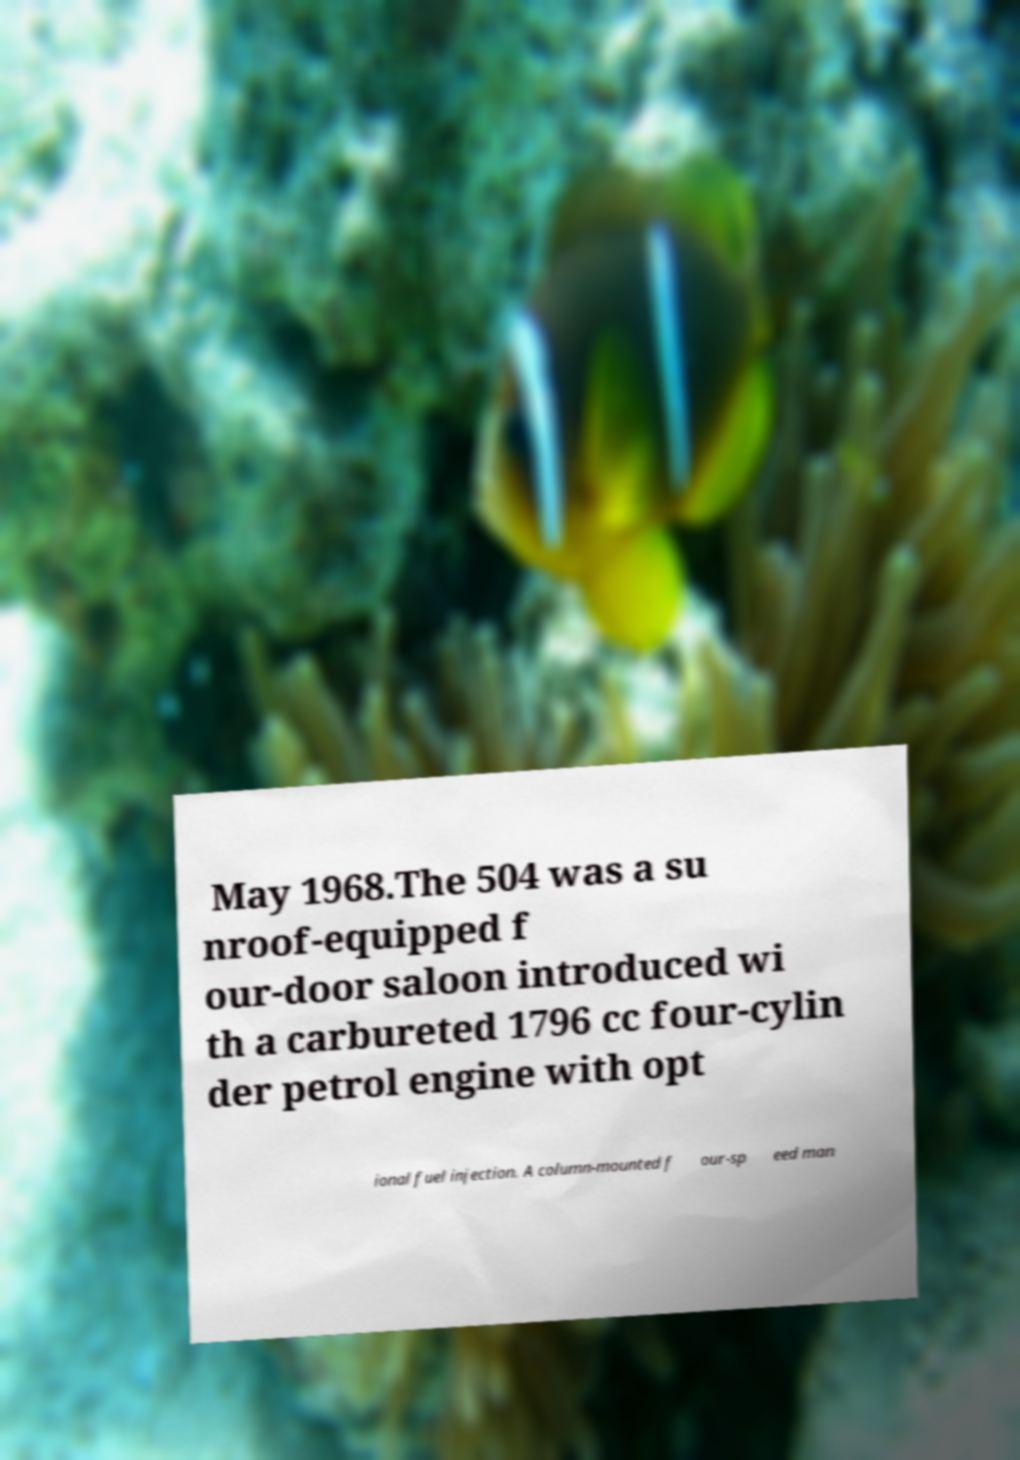Please identify and transcribe the text found in this image. May 1968.The 504 was a su nroof-equipped f our-door saloon introduced wi th a carbureted 1796 cc four-cylin der petrol engine with opt ional fuel injection. A column-mounted f our-sp eed man 